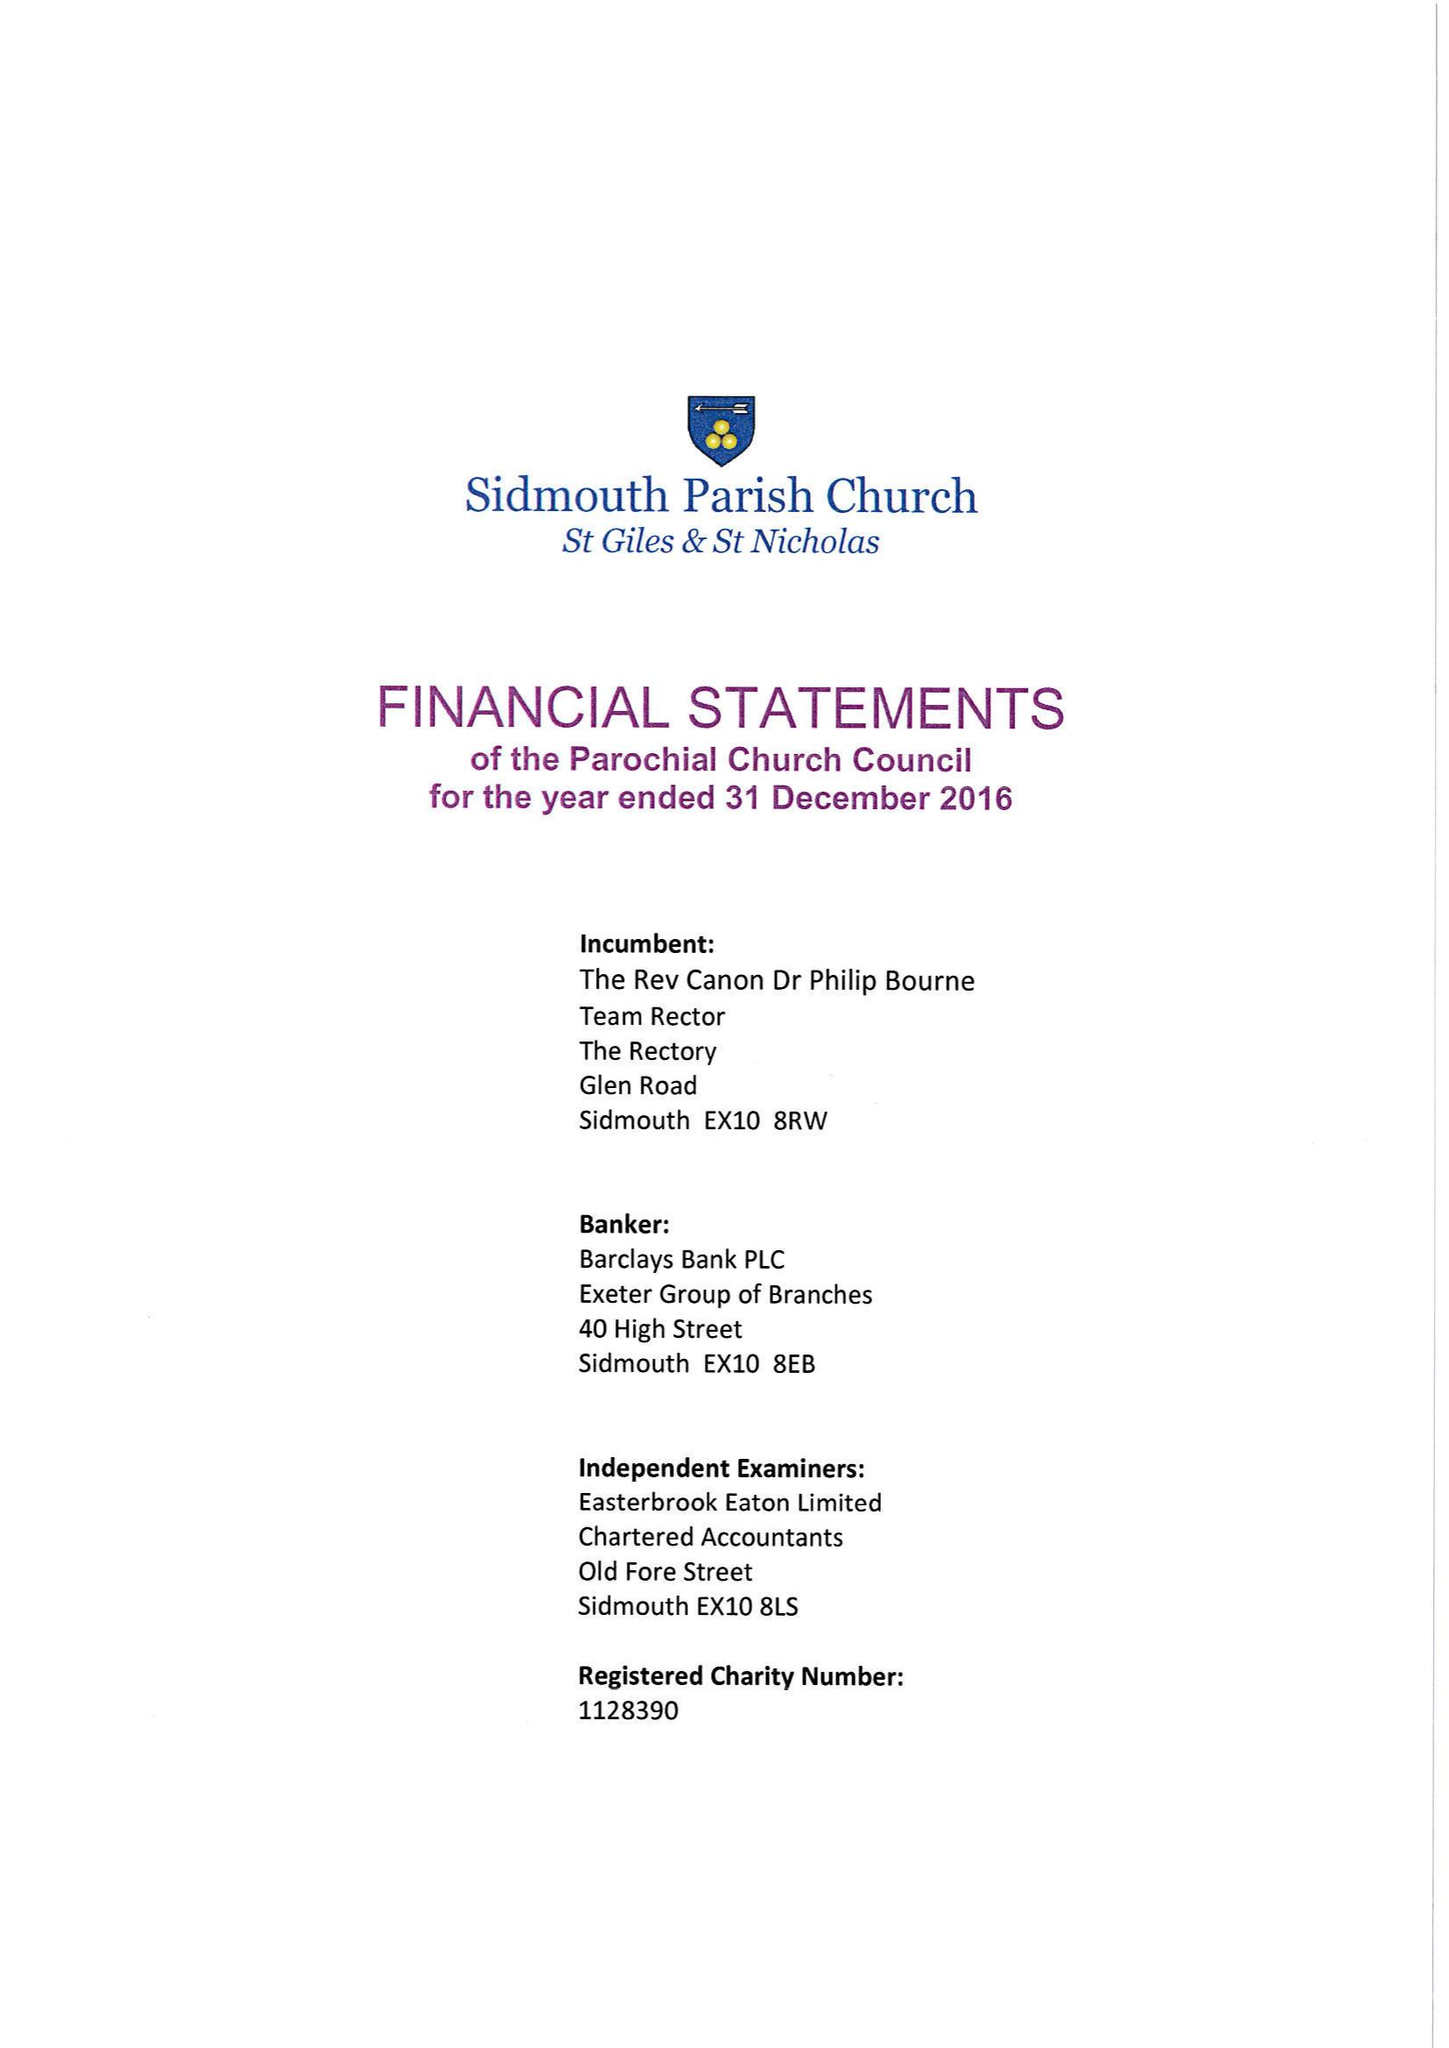What is the value for the address__post_town?
Answer the question using a single word or phrase. OTTERY ST. MARY 